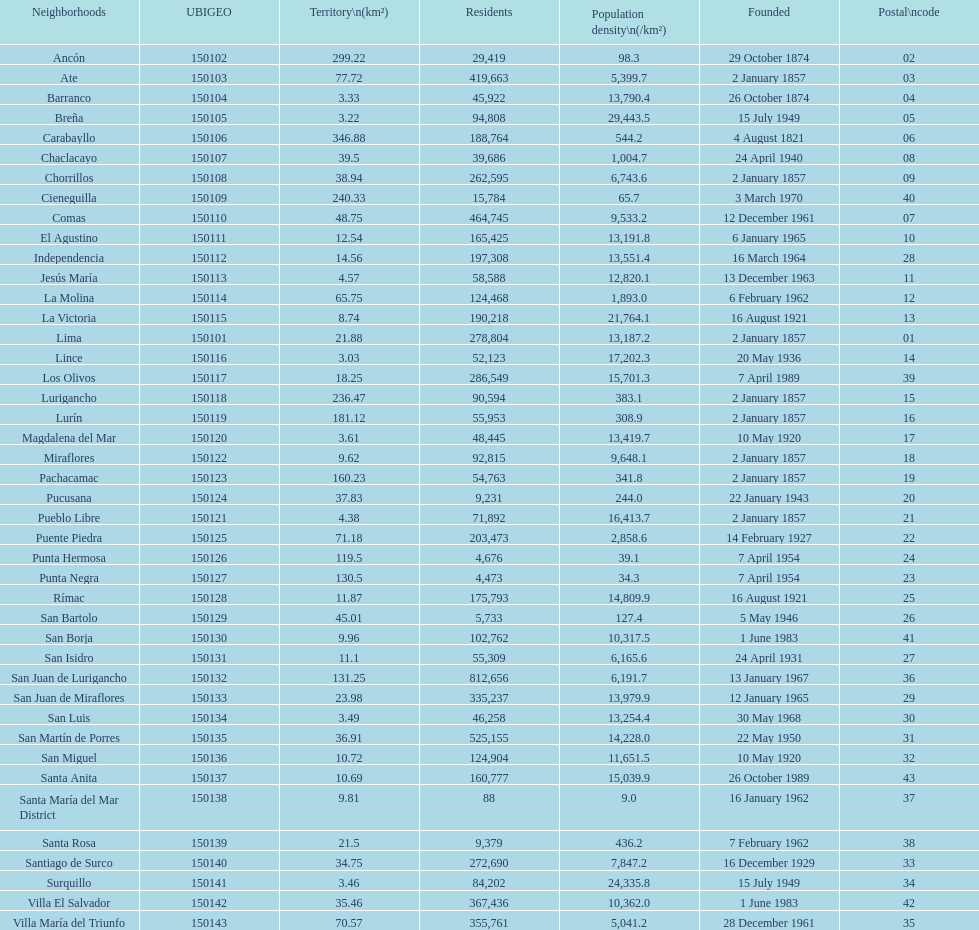How many districts have a population density of at lest 1000.0? 31. 